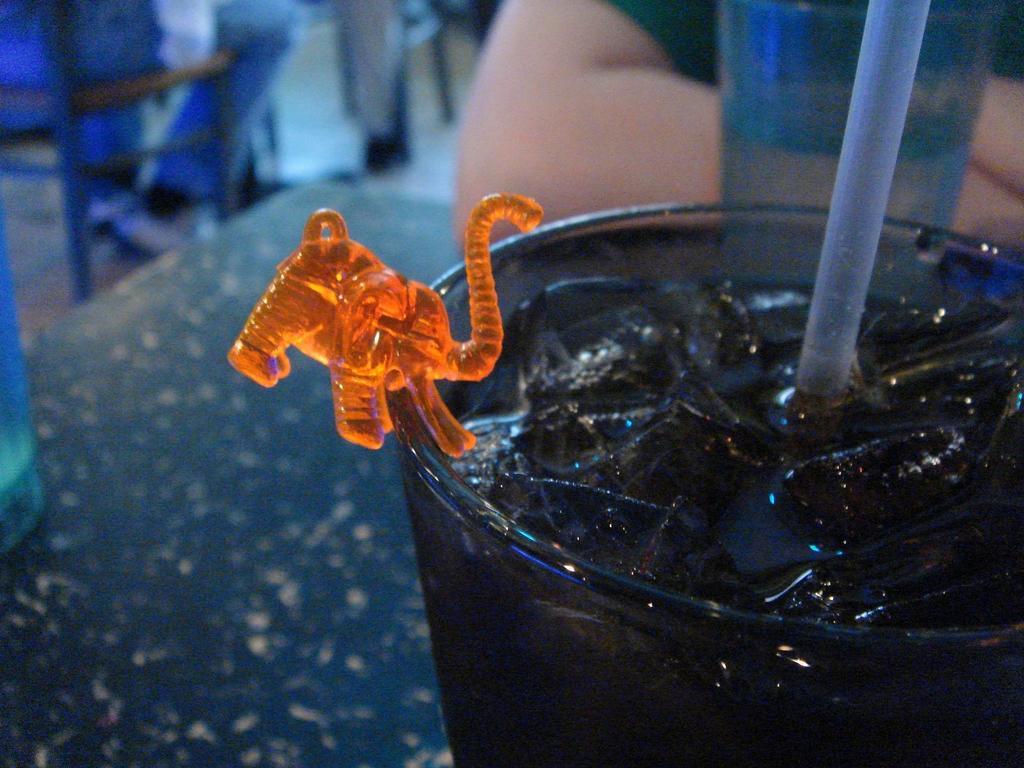How would you summarize this image in a sentence or two? In this picture there is a glass at the bottom right. In the glass there are ice cubes, straw and an elephant structure is attached to the glass. Behind the glass, there is a person. On the top left there is a person sitting on the chair. 